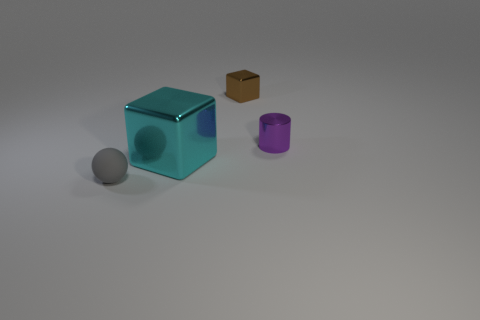Add 4 big objects. How many objects exist? 8 Subtract all spheres. How many objects are left? 3 Add 1 brown metallic things. How many brown metallic things are left? 2 Add 4 metallic objects. How many metallic objects exist? 7 Subtract 0 cyan spheres. How many objects are left? 4 Subtract all purple shiny objects. Subtract all purple metal objects. How many objects are left? 2 